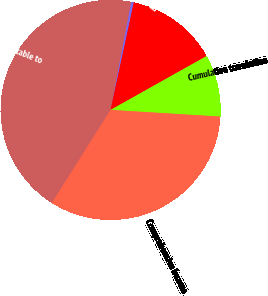Convert chart to OTSL. <chart><loc_0><loc_0><loc_500><loc_500><pie_chart><fcel>Net Income Attributable to<fcel>Net unrealized gain (loss) on<fcel>Benefit plan net (loss) gain<fcel>Cumulative translation<fcel>Comprehensive Income<nl><fcel>44.06%<fcel>0.37%<fcel>13.48%<fcel>9.11%<fcel>32.99%<nl></chart> 